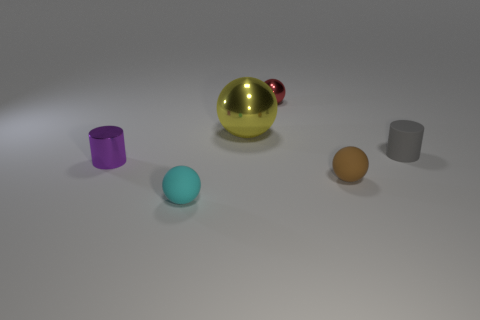How many objects are in the image, and can you describe their colors? There are five objects in the image. Starting from the left, there is a purple cylinder, a blue sphere, a golden sphere with a red highlight, a brown sphere, and a grey cylinder. 